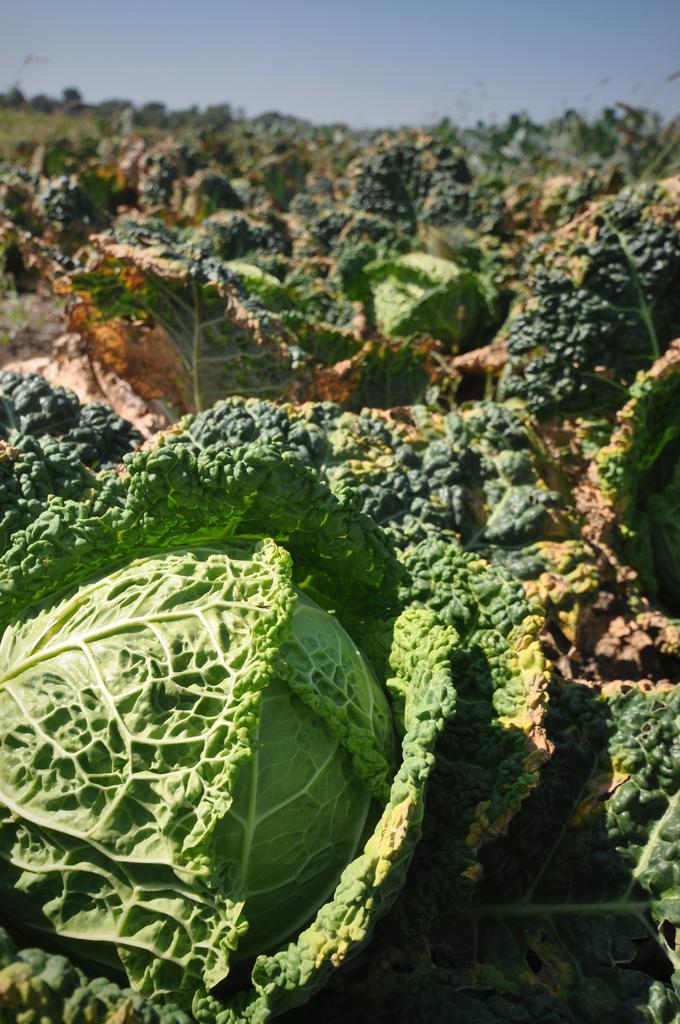Describe this image in one or two sentences. This picture shows cabbages and its leaves and we see trees and a cloudy Sky. 